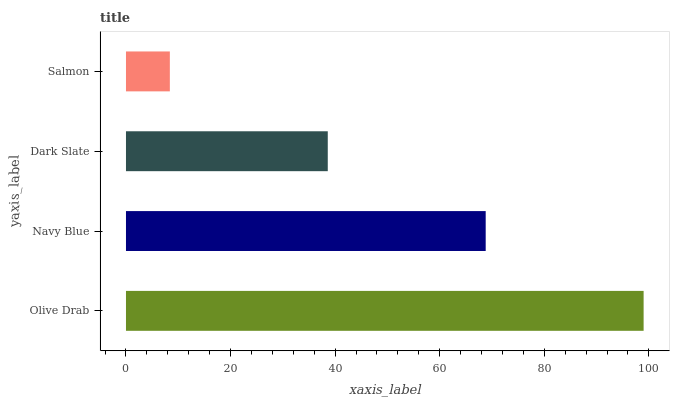Is Salmon the minimum?
Answer yes or no. Yes. Is Olive Drab the maximum?
Answer yes or no. Yes. Is Navy Blue the minimum?
Answer yes or no. No. Is Navy Blue the maximum?
Answer yes or no. No. Is Olive Drab greater than Navy Blue?
Answer yes or no. Yes. Is Navy Blue less than Olive Drab?
Answer yes or no. Yes. Is Navy Blue greater than Olive Drab?
Answer yes or no. No. Is Olive Drab less than Navy Blue?
Answer yes or no. No. Is Navy Blue the high median?
Answer yes or no. Yes. Is Dark Slate the low median?
Answer yes or no. Yes. Is Salmon the high median?
Answer yes or no. No. Is Navy Blue the low median?
Answer yes or no. No. 